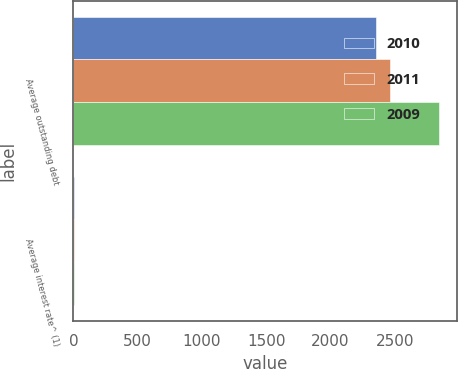<chart> <loc_0><loc_0><loc_500><loc_500><stacked_bar_chart><ecel><fcel>Average outstanding debt<fcel>Average interest rate^ (1)<nl><fcel>2010<fcel>2351.3<fcel>3.6<nl><fcel>2011<fcel>2461<fcel>4.8<nl><fcel>2009<fcel>2843.7<fcel>4.9<nl></chart> 